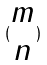<formula> <loc_0><loc_0><loc_500><loc_500>( \begin{matrix} m \\ n \end{matrix} )</formula> 